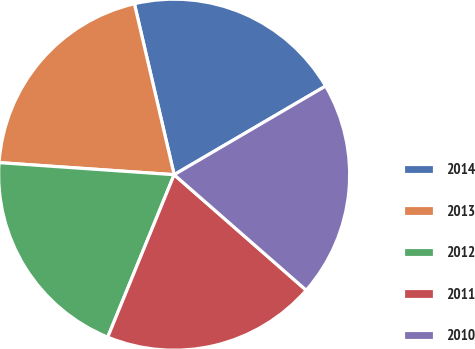<chart> <loc_0><loc_0><loc_500><loc_500><pie_chart><fcel>2014<fcel>2013<fcel>2012<fcel>2011<fcel>2010<nl><fcel>20.21%<fcel>20.27%<fcel>19.92%<fcel>19.74%<fcel>19.87%<nl></chart> 